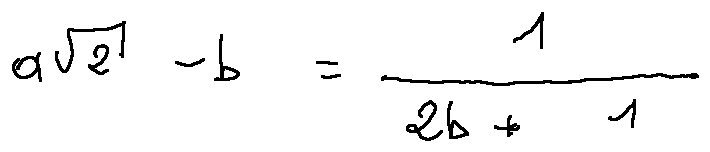<formula> <loc_0><loc_0><loc_500><loc_500>a \sqrt { 2 } - b = \frac { 1 } { 2 b + 1 }</formula> 